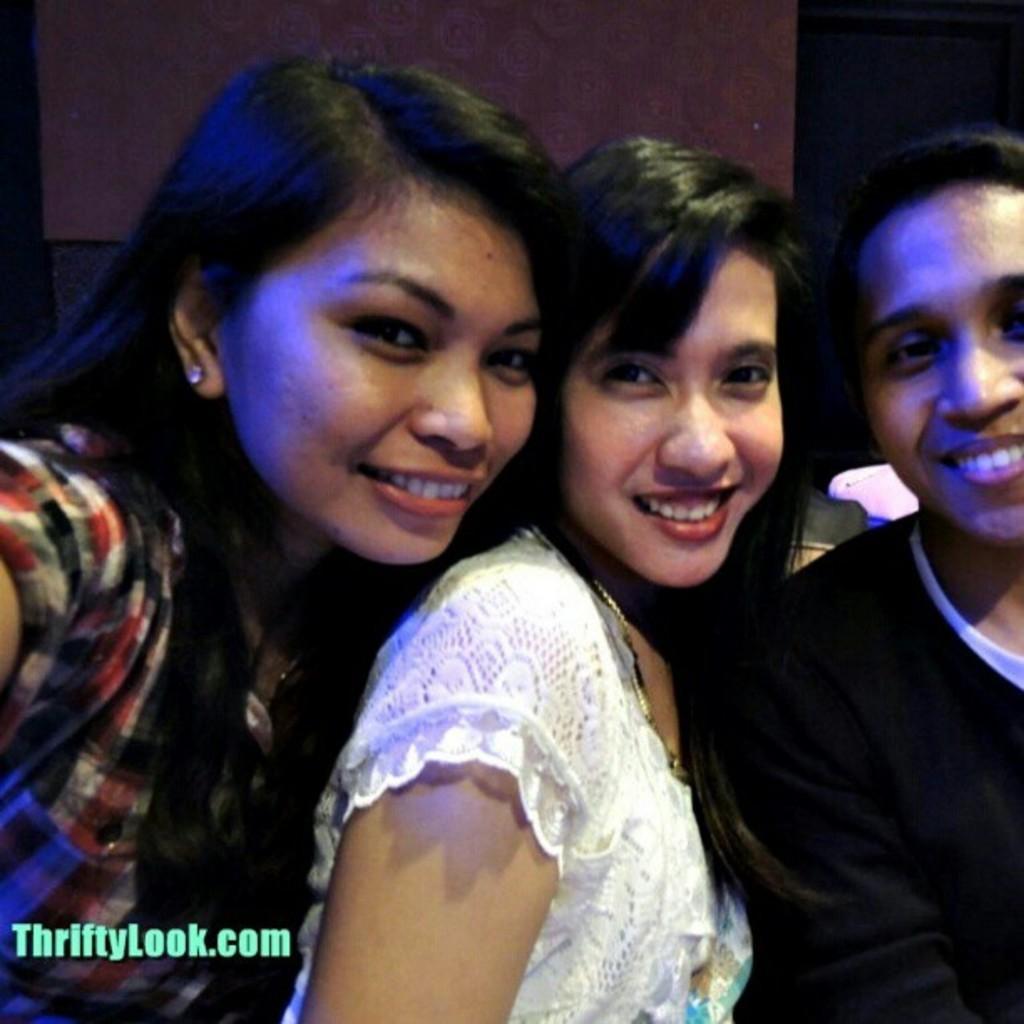Describe this image in one or two sentences. As we can see in the image there are three people standing in the front. The woman in the middle is wearing white color dress and behind them there is a wall. 